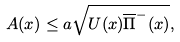Convert formula to latex. <formula><loc_0><loc_0><loc_500><loc_500>A ( x ) \leq a \sqrt { U ( x ) \overline { \Pi } ^ { - } ( x ) } ,</formula> 